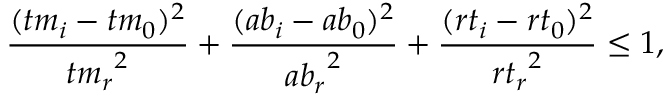<formula> <loc_0><loc_0><loc_500><loc_500>\frac { ( { t m } _ { i } - { t m } _ { 0 } ) ^ { 2 } } { { { t m } _ { r } } ^ { 2 } } + \frac { ( { a b } _ { i } - { a b } _ { 0 } ) ^ { 2 } } { { { a b } _ { r } } ^ { 2 } } + \frac { ( { r t } _ { i } - { r t } _ { 0 } ) ^ { 2 } } { { { r t } _ { r } } ^ { 2 } } \leq 1 ,</formula> 